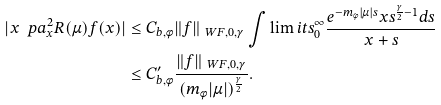Convert formula to latex. <formula><loc_0><loc_0><loc_500><loc_500>| x \ p a ^ { 2 } _ { x } R ( \mu ) f ( x ) | & \leq C _ { b , \phi } \| f \| _ { \ W F , 0 , \gamma } \int \lim i t s _ { 0 } ^ { \infty } \frac { e ^ { - m _ { \phi } | \mu | s } x s ^ { \frac { \gamma } { 2 } - 1 } d s } { x + s } \\ & \leq C ^ { \prime } _ { b , \phi } \frac { \| f \| _ { \ W F , 0 , \gamma } } { ( m _ { \phi } | \mu | ) ^ { \frac { \gamma } { 2 } } } .</formula> 